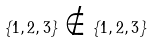<formula> <loc_0><loc_0><loc_500><loc_500>\{ 1 , 2 , 3 \} \notin \{ 1 , 2 , 3 \}</formula> 